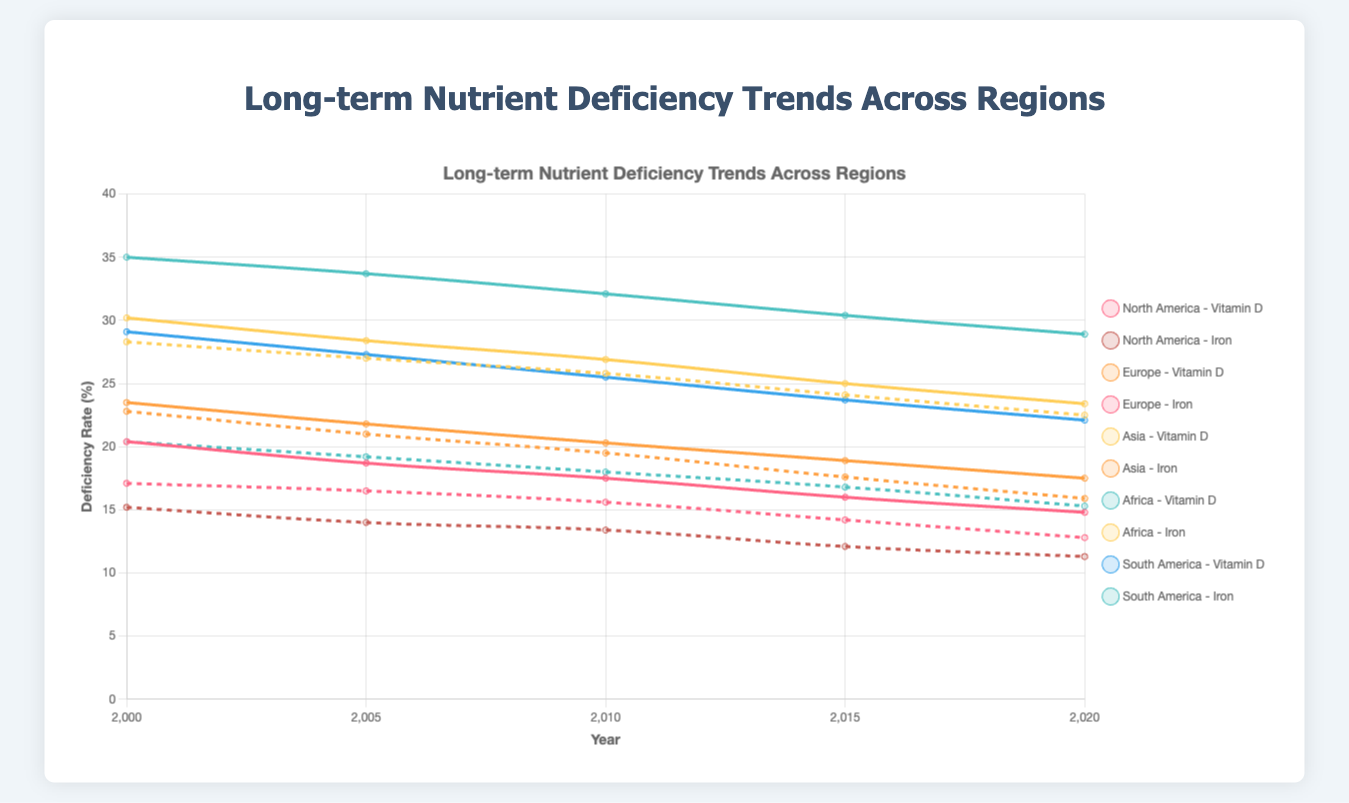Which region had the highest vitamin D deficiency in 2020? The line representing Africa has the highest value at 28.9% in 2020 according to the figure.
Answer: Africa How did the vitamin D deficiency rates in North America change from 2000 to 2020? The deficiency rate decreased from 20.4% in 2000 to 14.8% in 2020, indicating a drop of 5.6%.
Answer: Decreased by 5.6% What is the average iron deficiency rate in South America over the years shown? Sum of iron deficiencies over the years (20.4 + 19.2 + 18.0 + 16.8 + 15.3) = 89.7. Number of years = 5. Average = 89.7 / 5 = 17.94%.
Answer: 17.94% Which region experienced the greatest decrease in iron deficiency from 2000 to 2020? Calculate the difference for each region: North America (15.2 - 11.3 = 3.9), Europe (17.1 - 12.8 = 4.3), Asia (22.8 - 15.9 = 6.9), Africa (28.3 - 22.5 = 5.8), South America (20.4 - 15.3 = 5.1). Asia experienced the greatest decrease of 6.9%.
Answer: Asia Which region had the lowest iron deficiency rate in 2015? The figure shows North America had the lowest rate at 12.1% in 2015.
Answer: North America How did Europe’s vitamin D deficiency trend between 2000 and 2020? Europe’s trend shows a consistent decrease from 23.5% in 2000 to 17.5% in 2020, representing a steady decline.
Answer: Decreased Compare the vitamin D deficiency rate of Africa and Asia in 2005. Which one was higher and by how much? The figure indicates Africa at 33.7% and Asia at 28.4% in 2005, so Africa was higher by 33.7% - 28.4% = 5.3%.
Answer: Africa by 5.3% Which region shows the sharpest decline in vitamin D deficiency from 2010 to 2015? Look for the steepest slope between 2010 and 2015. North America declines from 17.5% to 16.0% (1.5%), Europe from 20.3% to 18.9% (1.4%), Asia from 26.9% to 25.0% (1.9%), Africa from 32.1% to 30.4% (1.7%), and South America from 25.5% to 23.7% (1.8%). Asia shows the sharpest decline of 1.9%.
Answer: Asia 